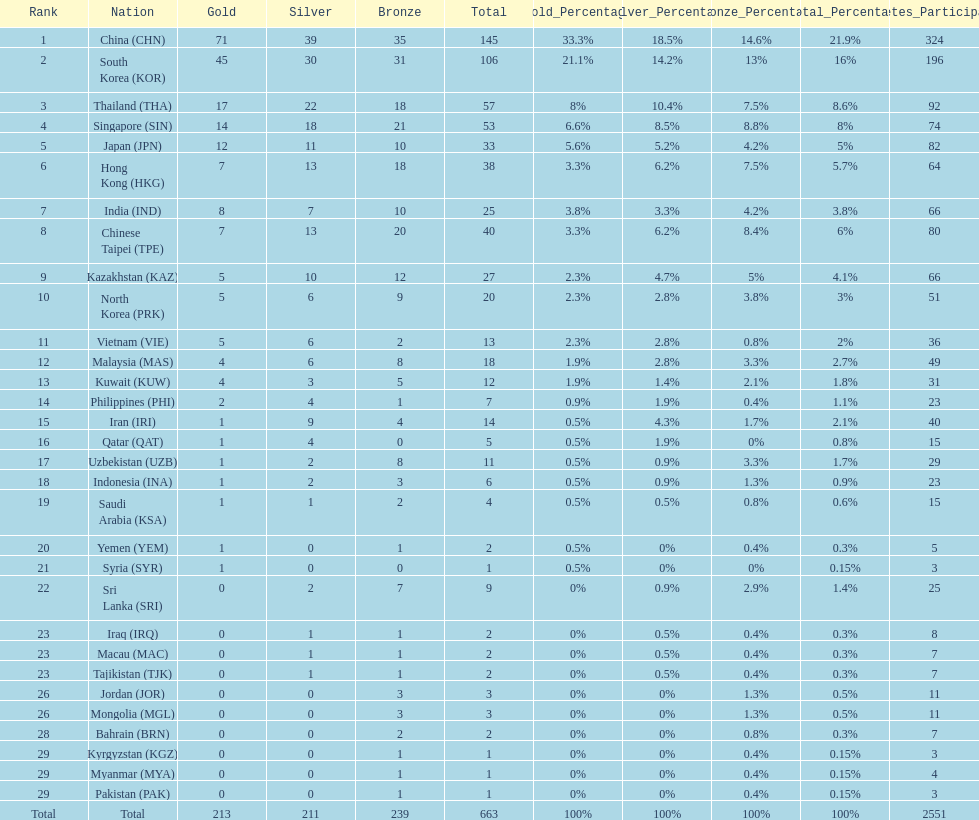What is the total number of medals that india won in the asian youth games? 25. 